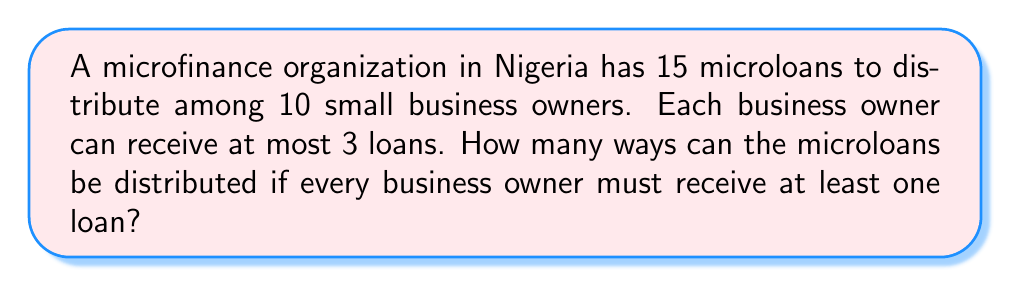Could you help me with this problem? Let's approach this step-by-step using the stars and bars method with restrictions:

1) First, we need to ensure each business owner gets at least one loan. This means we start by distributing 10 loans, one to each owner.

2) We now have 5 loans left to distribute among 10 owners, with each owner able to receive up to 2 more loans (since they already have 1, and the maximum is 3).

3) This scenario can be modeled as distributing 5 identical objects (remaining loans) into 10 distinct boxes (business owners), where each box can hold up to 2 objects.

4) We can use the Inclusion-Exclusion Principle to solve this:

   Let $A_i$ be the event that the $i$-th owner receives more than 2 additional loans.

5) The total number of ways to distribute 5 loans to 10 owners without restrictions is:
   
   $$\binom{5+10-1}{10-1} = \binom{14}{9}$$

6) Number of ways where at least one owner gets more than 2 additional loans:

   $$\sum_{i=1}^{10} \binom{10}{i} \binom{5-3i+10-1}{10-1}$$

7) Using the Inclusion-Exclusion Principle:

   $$\text{Answer} = \binom{14}{9} - \sum_{i=1}^{10} (-1)^{i-1} \binom{10}{i} \binom{5-3i+10-1}{10-1}$$

8) Calculating this:
   
   $$\binom{14}{9} - \binom{10}{1}\binom{11}{9} + \binom{10}{2}\binom{8}{9} = 2002 - 1100 + 0 = 902$$
Answer: 902 